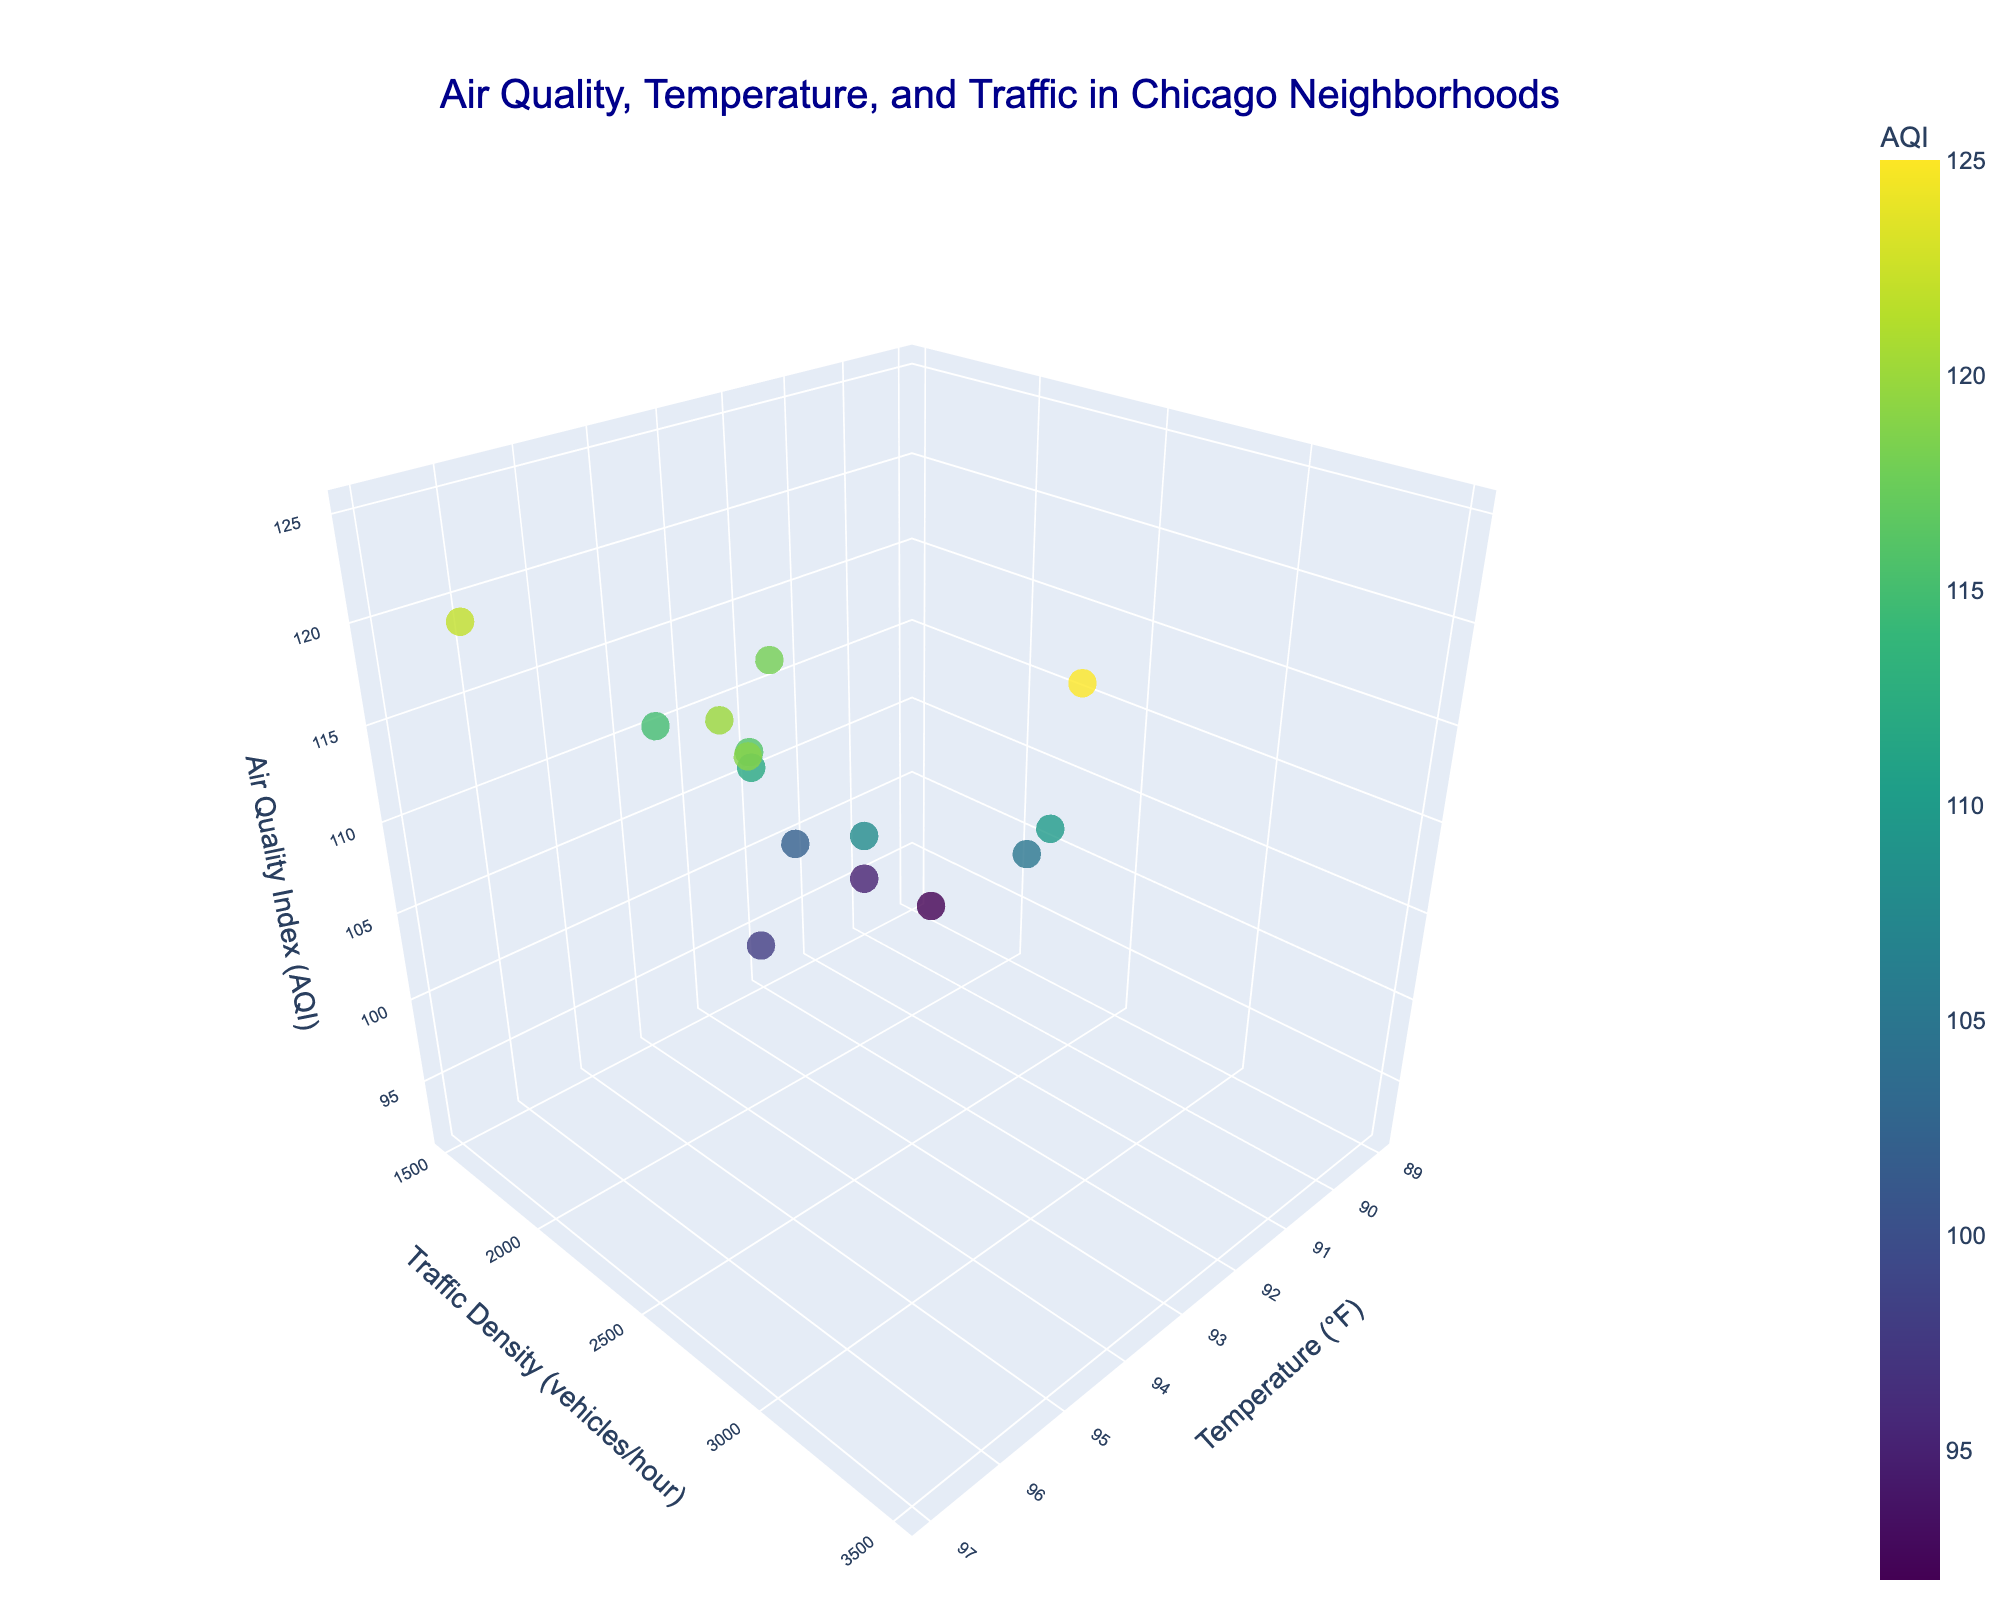What is the title of the plot? The title of the plot is prominently displayed at the top of the figure and usually gives an overview of what the plot represents.
Answer: Air Quality, Temperature, and Traffic in Chicago Neighborhoods What does the color of a marker represent? In the plot, the colors of the markers correspond to the values of the Air Quality Index (AQI). This is indicated by the color bar on the right side.
Answer: Air Quality Index (AQI) Which neighborhood has the highest Air Quality Index (AQI)? To determine which neighborhood has the highest AQI, locate the marker with the highest z-axis value. Check the hover information for the neighborhood name.
Answer: Humboldt Park How does the Traffic Density in Loop compare to that in Hyde Park? Locate the markers representing Loop and Hyde Park using the hover information, then compare their positions along the y-axis, which denotes Traffic Density.
Answer: Loop has higher traffic density than Hyde Park What can you infer about the relationship between Temperature and AQI? Inspect the overall pattern of the markers. Generally, markers with higher temperature (x-axis) tend to have higher AQI (z-axis), suggesting a positive correlation.
Answer: Higher temperature correlates with higher AQI Which neighborhoods have similar Traffic Density and Air Quality Index? Look for markers close to each other along the y-axis (Traffic Density) and z-axis (AQI). Use the hover information to confirm the neighborhood names.
Answer: Pilsen and Bronzeville Is there any neighborhood with both low temperature and high AQI? Find the markers with low values along the x-axis (Temperature) and high values along the z-axis (AQI). Use the hover information to identify the neighborhood.
Answer: No, there are no such neighborhoods What's the average Air Quality Index (AQI) of the neighborhoods? Sum all the AQI values and divide by the number of neighborhoods (15). Calculation: (125 + 110 + 118 + 105 + 98 + 120 + 115 + 95 + 102 + 122 + 108 + 116 + 112 + 92 + 119) / 15 = 106.
Answer: 106 What is the adjacent neighborhood to Wicker Park with the closest Traffic Density and higher Air Quality Index? Locate Wicker Park on the plot and identify the adjacent marker with similar Traffic Density (y-axis) but a higher AQI (z-axis).
Answer: Bucktown 